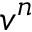<formula> <loc_0><loc_0><loc_500><loc_500>v ^ { n }</formula> 